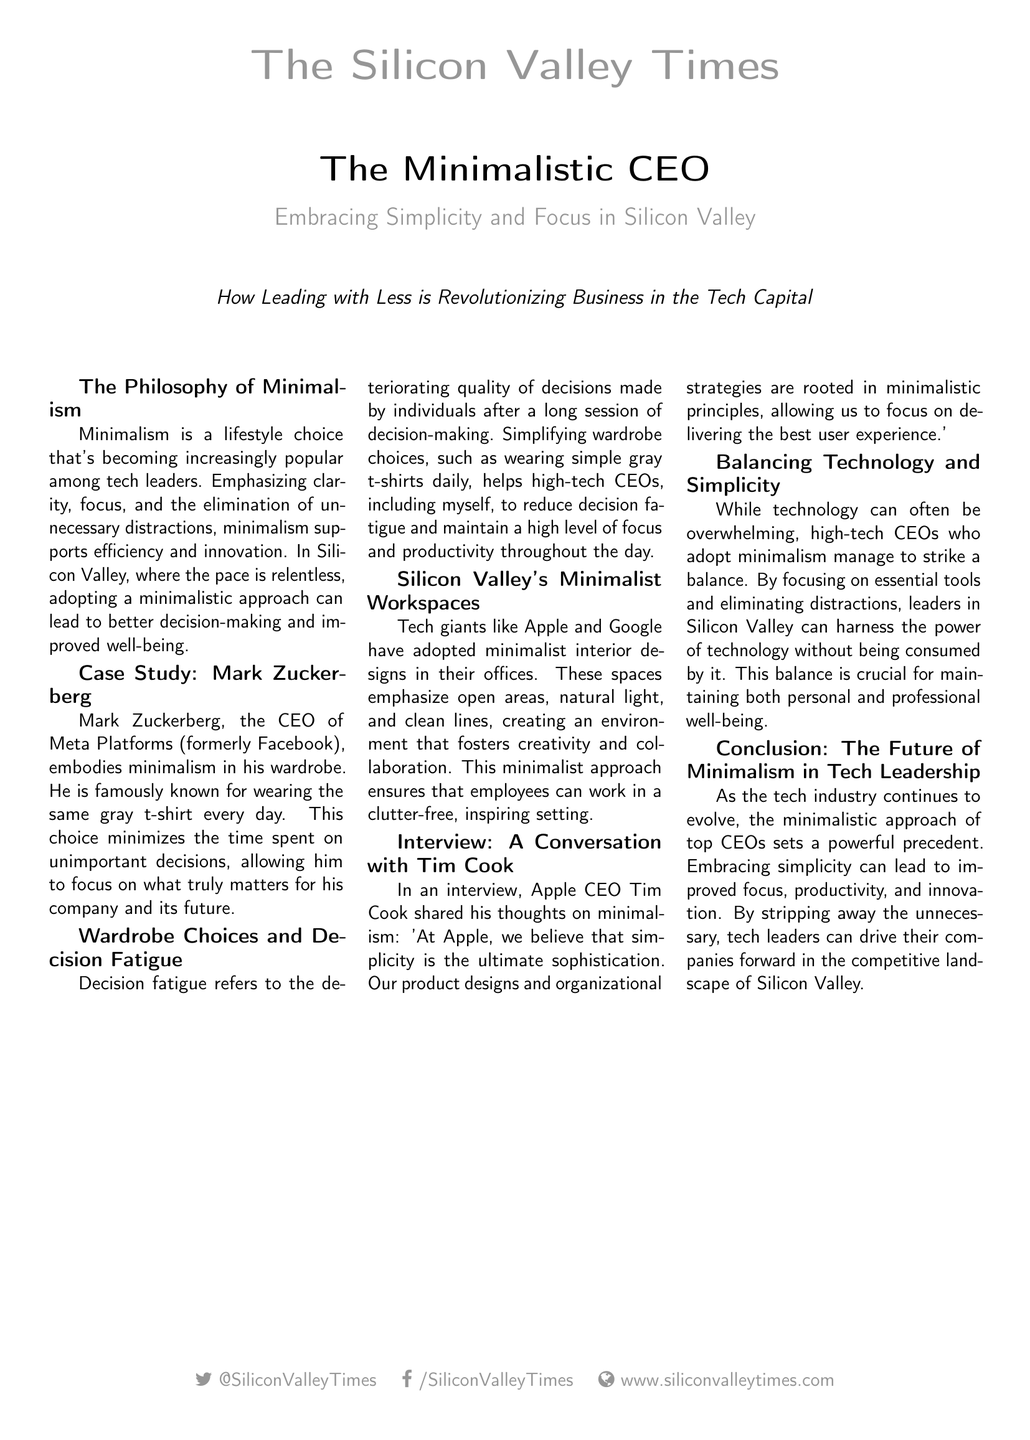What is the title of the document? The title of the document is prominently displayed at the top of the layout, which is "The Minimalistic CEO".
Answer: The Minimalistic CEO Who is the CEO of Meta Platforms mentioned in the document? The document includes a case study of Mark Zuckerberg, who is identified as the CEO of Meta Platforms.
Answer: Mark Zuckerberg What does Tim Cook say about simplicity? In the interview excerpt, Tim Cook expresses that "simplicity is the ultimate sophistication."
Answer: Simplicity is the ultimate sophistication What is the primary benefit of adopting a minimalist wardrobe for CEOs? The document mentions that simplifying wardrobe choices helps reduce decision fatigue, which is a key benefit for high-tech CEOs.
Answer: Reducing decision fatigue Which two tech giants are noted for adopting minimalist workspaces? The document specifically mentions Apple and Google as examples of tech giants with minimalist interior designs in their offices.
Answer: Apple and Google What does the document suggest about the future of minimalism in tech leadership? The conclusion of the document indicates that embracing minimalism can lead to improved focus, productivity, and innovation in the tech industry.
Answer: Improved focus, productivity, and innovation How many articles are presented in the multicols section? The multicols section contains a series of news items, which total to seven articles related to the topic of minimalism in tech leadership.
Answer: Seven articles What color is associated with the CEO's t-shirt in the case study? The case study specifically describes Mark Zuckerberg as wearing a gray t-shirt.
Answer: Gray t-shirt What is the main theme of the document? The document centers around how minimalism in leadership can enhance efficiency and decision-making in the tech environment.
Answer: Enhancing efficiency and decision-making 